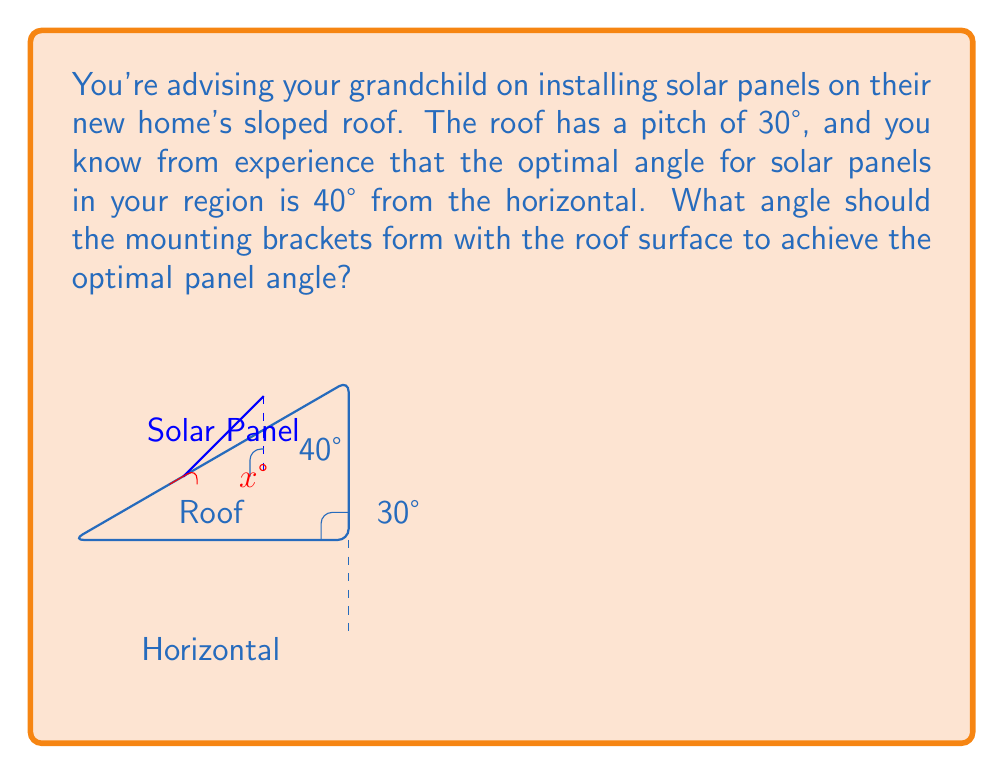Provide a solution to this math problem. Let's approach this step-by-step:

1) First, we need to understand what we're looking for. We want to find the angle between the roof and the solar panel, which we'll call $x$.

2) We know two important angles:
   - The roof pitch is 30° from the horizontal
   - The optimal solar panel angle is 40° from the horizontal

3) We can use the concept of supplementary angles here. The angle we're looking for ($x$) plus the roof angle (30°) should equal the optimal panel angle (40°).

4) We can express this as an equation:

   $$ x + 30° = 40° $$

5) To solve for $x$, we simply subtract 30° from both sides:

   $$ x = 40° - 30° = 10° $$

6) Therefore, the mounting brackets should form a 10° angle with the roof surface to achieve the optimal panel angle of 40° from the horizontal.

This solution balances the traditional understanding of roof construction with the modern need for optimal solar energy collection, demonstrating how practical experience can be applied to sustainable technologies.
Answer: 10° 